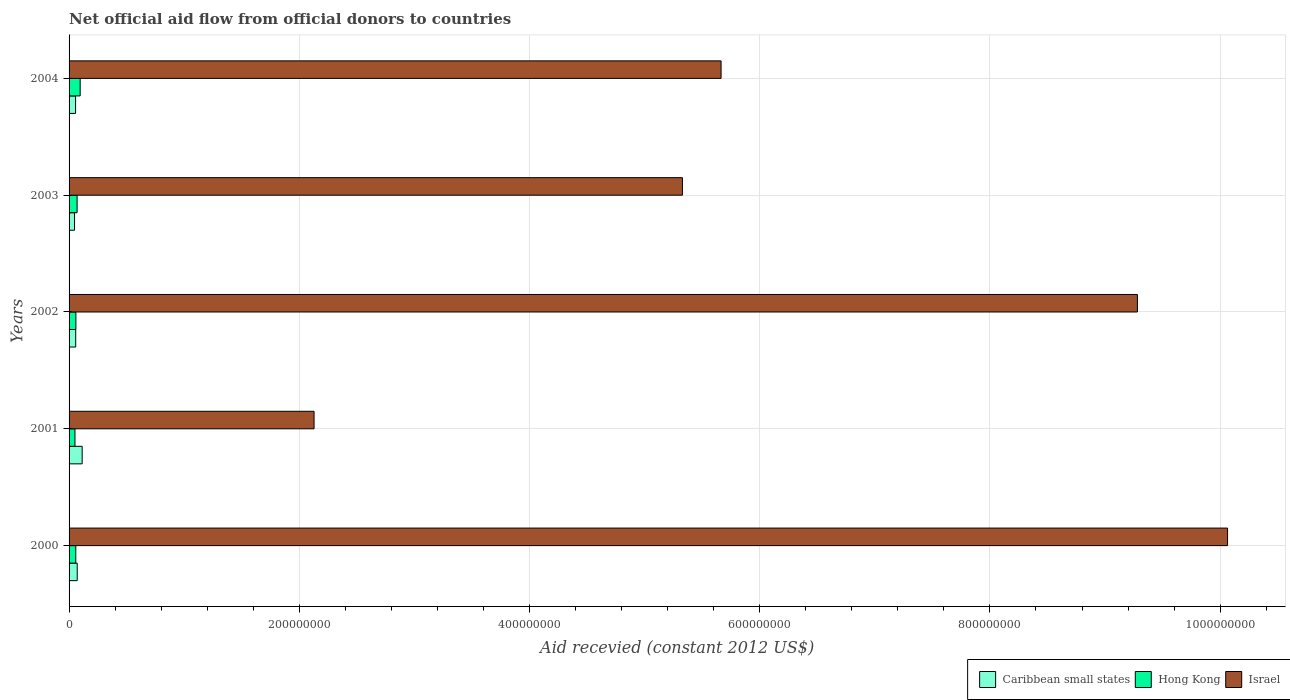How many different coloured bars are there?
Offer a terse response. 3. How many groups of bars are there?
Give a very brief answer. 5. How many bars are there on the 5th tick from the bottom?
Provide a short and direct response. 3. What is the total aid received in Caribbean small states in 2002?
Provide a short and direct response. 5.78e+06. Across all years, what is the maximum total aid received in Caribbean small states?
Make the answer very short. 1.14e+07. Across all years, what is the minimum total aid received in Israel?
Your answer should be compact. 2.13e+08. In which year was the total aid received in Israel maximum?
Offer a very short reply. 2000. What is the total total aid received in Hong Kong in the graph?
Your response must be concise. 3.35e+07. What is the difference between the total aid received in Caribbean small states in 2000 and that in 2004?
Keep it short and to the point. 1.42e+06. What is the difference between the total aid received in Israel in 2000 and the total aid received in Caribbean small states in 2003?
Your answer should be very brief. 1.00e+09. What is the average total aid received in Hong Kong per year?
Offer a very short reply. 6.70e+06. In the year 2000, what is the difference between the total aid received in Israel and total aid received in Hong Kong?
Make the answer very short. 1.00e+09. What is the ratio of the total aid received in Hong Kong in 2000 to that in 2004?
Offer a terse response. 0.6. Is the total aid received in Caribbean small states in 2000 less than that in 2002?
Offer a terse response. No. Is the difference between the total aid received in Israel in 2003 and 2004 greater than the difference between the total aid received in Hong Kong in 2003 and 2004?
Provide a succinct answer. No. What is the difference between the highest and the second highest total aid received in Caribbean small states?
Your answer should be very brief. 4.30e+06. What is the difference between the highest and the lowest total aid received in Israel?
Provide a short and direct response. 7.94e+08. Is the sum of the total aid received in Israel in 2002 and 2003 greater than the maximum total aid received in Caribbean small states across all years?
Make the answer very short. Yes. What does the 2nd bar from the top in 2002 represents?
Offer a terse response. Hong Kong. What does the 2nd bar from the bottom in 2002 represents?
Your answer should be compact. Hong Kong. Is it the case that in every year, the sum of the total aid received in Caribbean small states and total aid received in Israel is greater than the total aid received in Hong Kong?
Your response must be concise. Yes. How many bars are there?
Your response must be concise. 15. How many years are there in the graph?
Offer a very short reply. 5. What is the difference between two consecutive major ticks on the X-axis?
Offer a terse response. 2.00e+08. Are the values on the major ticks of X-axis written in scientific E-notation?
Your response must be concise. No. Does the graph contain any zero values?
Offer a terse response. No. Where does the legend appear in the graph?
Your answer should be compact. Bottom right. How many legend labels are there?
Offer a very short reply. 3. What is the title of the graph?
Provide a short and direct response. Net official aid flow from official donors to countries. What is the label or title of the X-axis?
Your answer should be very brief. Aid recevied (constant 2012 US$). What is the Aid recevied (constant 2012 US$) of Caribbean small states in 2000?
Your response must be concise. 7.08e+06. What is the Aid recevied (constant 2012 US$) in Hong Kong in 2000?
Your answer should be very brief. 5.83e+06. What is the Aid recevied (constant 2012 US$) in Israel in 2000?
Ensure brevity in your answer.  1.01e+09. What is the Aid recevied (constant 2012 US$) in Caribbean small states in 2001?
Give a very brief answer. 1.14e+07. What is the Aid recevied (constant 2012 US$) in Hong Kong in 2001?
Give a very brief answer. 5.12e+06. What is the Aid recevied (constant 2012 US$) in Israel in 2001?
Provide a short and direct response. 2.13e+08. What is the Aid recevied (constant 2012 US$) of Caribbean small states in 2002?
Make the answer very short. 5.78e+06. What is the Aid recevied (constant 2012 US$) in Hong Kong in 2002?
Your answer should be very brief. 5.92e+06. What is the Aid recevied (constant 2012 US$) in Israel in 2002?
Make the answer very short. 9.28e+08. What is the Aid recevied (constant 2012 US$) of Caribbean small states in 2003?
Keep it short and to the point. 4.76e+06. What is the Aid recevied (constant 2012 US$) in Hong Kong in 2003?
Offer a terse response. 6.99e+06. What is the Aid recevied (constant 2012 US$) in Israel in 2003?
Offer a very short reply. 5.33e+08. What is the Aid recevied (constant 2012 US$) of Caribbean small states in 2004?
Your answer should be very brief. 5.66e+06. What is the Aid recevied (constant 2012 US$) of Hong Kong in 2004?
Offer a terse response. 9.65e+06. What is the Aid recevied (constant 2012 US$) of Israel in 2004?
Your response must be concise. 5.66e+08. Across all years, what is the maximum Aid recevied (constant 2012 US$) in Caribbean small states?
Offer a very short reply. 1.14e+07. Across all years, what is the maximum Aid recevied (constant 2012 US$) in Hong Kong?
Offer a terse response. 9.65e+06. Across all years, what is the maximum Aid recevied (constant 2012 US$) of Israel?
Provide a succinct answer. 1.01e+09. Across all years, what is the minimum Aid recevied (constant 2012 US$) in Caribbean small states?
Make the answer very short. 4.76e+06. Across all years, what is the minimum Aid recevied (constant 2012 US$) of Hong Kong?
Your response must be concise. 5.12e+06. Across all years, what is the minimum Aid recevied (constant 2012 US$) of Israel?
Keep it short and to the point. 2.13e+08. What is the total Aid recevied (constant 2012 US$) in Caribbean small states in the graph?
Provide a short and direct response. 3.47e+07. What is the total Aid recevied (constant 2012 US$) of Hong Kong in the graph?
Offer a very short reply. 3.35e+07. What is the total Aid recevied (constant 2012 US$) in Israel in the graph?
Ensure brevity in your answer.  3.25e+09. What is the difference between the Aid recevied (constant 2012 US$) in Caribbean small states in 2000 and that in 2001?
Provide a succinct answer. -4.30e+06. What is the difference between the Aid recevied (constant 2012 US$) of Hong Kong in 2000 and that in 2001?
Your answer should be compact. 7.10e+05. What is the difference between the Aid recevied (constant 2012 US$) of Israel in 2000 and that in 2001?
Ensure brevity in your answer.  7.94e+08. What is the difference between the Aid recevied (constant 2012 US$) in Caribbean small states in 2000 and that in 2002?
Offer a very short reply. 1.30e+06. What is the difference between the Aid recevied (constant 2012 US$) of Hong Kong in 2000 and that in 2002?
Offer a very short reply. -9.00e+04. What is the difference between the Aid recevied (constant 2012 US$) in Israel in 2000 and that in 2002?
Your answer should be very brief. 7.83e+07. What is the difference between the Aid recevied (constant 2012 US$) in Caribbean small states in 2000 and that in 2003?
Ensure brevity in your answer.  2.32e+06. What is the difference between the Aid recevied (constant 2012 US$) in Hong Kong in 2000 and that in 2003?
Your response must be concise. -1.16e+06. What is the difference between the Aid recevied (constant 2012 US$) in Israel in 2000 and that in 2003?
Provide a succinct answer. 4.74e+08. What is the difference between the Aid recevied (constant 2012 US$) of Caribbean small states in 2000 and that in 2004?
Your response must be concise. 1.42e+06. What is the difference between the Aid recevied (constant 2012 US$) of Hong Kong in 2000 and that in 2004?
Keep it short and to the point. -3.82e+06. What is the difference between the Aid recevied (constant 2012 US$) in Israel in 2000 and that in 2004?
Your response must be concise. 4.40e+08. What is the difference between the Aid recevied (constant 2012 US$) in Caribbean small states in 2001 and that in 2002?
Keep it short and to the point. 5.60e+06. What is the difference between the Aid recevied (constant 2012 US$) of Hong Kong in 2001 and that in 2002?
Provide a short and direct response. -8.00e+05. What is the difference between the Aid recevied (constant 2012 US$) of Israel in 2001 and that in 2002?
Give a very brief answer. -7.15e+08. What is the difference between the Aid recevied (constant 2012 US$) in Caribbean small states in 2001 and that in 2003?
Provide a succinct answer. 6.62e+06. What is the difference between the Aid recevied (constant 2012 US$) of Hong Kong in 2001 and that in 2003?
Ensure brevity in your answer.  -1.87e+06. What is the difference between the Aid recevied (constant 2012 US$) of Israel in 2001 and that in 2003?
Your answer should be compact. -3.20e+08. What is the difference between the Aid recevied (constant 2012 US$) in Caribbean small states in 2001 and that in 2004?
Offer a terse response. 5.72e+06. What is the difference between the Aid recevied (constant 2012 US$) of Hong Kong in 2001 and that in 2004?
Offer a terse response. -4.53e+06. What is the difference between the Aid recevied (constant 2012 US$) in Israel in 2001 and that in 2004?
Offer a terse response. -3.54e+08. What is the difference between the Aid recevied (constant 2012 US$) of Caribbean small states in 2002 and that in 2003?
Your response must be concise. 1.02e+06. What is the difference between the Aid recevied (constant 2012 US$) of Hong Kong in 2002 and that in 2003?
Offer a very short reply. -1.07e+06. What is the difference between the Aid recevied (constant 2012 US$) of Israel in 2002 and that in 2003?
Provide a succinct answer. 3.95e+08. What is the difference between the Aid recevied (constant 2012 US$) in Caribbean small states in 2002 and that in 2004?
Make the answer very short. 1.20e+05. What is the difference between the Aid recevied (constant 2012 US$) of Hong Kong in 2002 and that in 2004?
Offer a terse response. -3.73e+06. What is the difference between the Aid recevied (constant 2012 US$) in Israel in 2002 and that in 2004?
Your answer should be compact. 3.62e+08. What is the difference between the Aid recevied (constant 2012 US$) of Caribbean small states in 2003 and that in 2004?
Keep it short and to the point. -9.00e+05. What is the difference between the Aid recevied (constant 2012 US$) of Hong Kong in 2003 and that in 2004?
Provide a succinct answer. -2.66e+06. What is the difference between the Aid recevied (constant 2012 US$) of Israel in 2003 and that in 2004?
Offer a terse response. -3.36e+07. What is the difference between the Aid recevied (constant 2012 US$) in Caribbean small states in 2000 and the Aid recevied (constant 2012 US$) in Hong Kong in 2001?
Make the answer very short. 1.96e+06. What is the difference between the Aid recevied (constant 2012 US$) of Caribbean small states in 2000 and the Aid recevied (constant 2012 US$) of Israel in 2001?
Offer a terse response. -2.06e+08. What is the difference between the Aid recevied (constant 2012 US$) in Hong Kong in 2000 and the Aid recevied (constant 2012 US$) in Israel in 2001?
Your answer should be very brief. -2.07e+08. What is the difference between the Aid recevied (constant 2012 US$) of Caribbean small states in 2000 and the Aid recevied (constant 2012 US$) of Hong Kong in 2002?
Offer a terse response. 1.16e+06. What is the difference between the Aid recevied (constant 2012 US$) in Caribbean small states in 2000 and the Aid recevied (constant 2012 US$) in Israel in 2002?
Your answer should be compact. -9.21e+08. What is the difference between the Aid recevied (constant 2012 US$) in Hong Kong in 2000 and the Aid recevied (constant 2012 US$) in Israel in 2002?
Make the answer very short. -9.22e+08. What is the difference between the Aid recevied (constant 2012 US$) of Caribbean small states in 2000 and the Aid recevied (constant 2012 US$) of Israel in 2003?
Your answer should be compact. -5.26e+08. What is the difference between the Aid recevied (constant 2012 US$) in Hong Kong in 2000 and the Aid recevied (constant 2012 US$) in Israel in 2003?
Keep it short and to the point. -5.27e+08. What is the difference between the Aid recevied (constant 2012 US$) in Caribbean small states in 2000 and the Aid recevied (constant 2012 US$) in Hong Kong in 2004?
Give a very brief answer. -2.57e+06. What is the difference between the Aid recevied (constant 2012 US$) in Caribbean small states in 2000 and the Aid recevied (constant 2012 US$) in Israel in 2004?
Make the answer very short. -5.59e+08. What is the difference between the Aid recevied (constant 2012 US$) of Hong Kong in 2000 and the Aid recevied (constant 2012 US$) of Israel in 2004?
Give a very brief answer. -5.61e+08. What is the difference between the Aid recevied (constant 2012 US$) in Caribbean small states in 2001 and the Aid recevied (constant 2012 US$) in Hong Kong in 2002?
Offer a terse response. 5.46e+06. What is the difference between the Aid recevied (constant 2012 US$) in Caribbean small states in 2001 and the Aid recevied (constant 2012 US$) in Israel in 2002?
Offer a terse response. -9.17e+08. What is the difference between the Aid recevied (constant 2012 US$) of Hong Kong in 2001 and the Aid recevied (constant 2012 US$) of Israel in 2002?
Your response must be concise. -9.23e+08. What is the difference between the Aid recevied (constant 2012 US$) in Caribbean small states in 2001 and the Aid recevied (constant 2012 US$) in Hong Kong in 2003?
Ensure brevity in your answer.  4.39e+06. What is the difference between the Aid recevied (constant 2012 US$) of Caribbean small states in 2001 and the Aid recevied (constant 2012 US$) of Israel in 2003?
Make the answer very short. -5.21e+08. What is the difference between the Aid recevied (constant 2012 US$) of Hong Kong in 2001 and the Aid recevied (constant 2012 US$) of Israel in 2003?
Your answer should be very brief. -5.28e+08. What is the difference between the Aid recevied (constant 2012 US$) in Caribbean small states in 2001 and the Aid recevied (constant 2012 US$) in Hong Kong in 2004?
Your response must be concise. 1.73e+06. What is the difference between the Aid recevied (constant 2012 US$) in Caribbean small states in 2001 and the Aid recevied (constant 2012 US$) in Israel in 2004?
Make the answer very short. -5.55e+08. What is the difference between the Aid recevied (constant 2012 US$) in Hong Kong in 2001 and the Aid recevied (constant 2012 US$) in Israel in 2004?
Offer a terse response. -5.61e+08. What is the difference between the Aid recevied (constant 2012 US$) in Caribbean small states in 2002 and the Aid recevied (constant 2012 US$) in Hong Kong in 2003?
Your answer should be compact. -1.21e+06. What is the difference between the Aid recevied (constant 2012 US$) in Caribbean small states in 2002 and the Aid recevied (constant 2012 US$) in Israel in 2003?
Offer a terse response. -5.27e+08. What is the difference between the Aid recevied (constant 2012 US$) in Hong Kong in 2002 and the Aid recevied (constant 2012 US$) in Israel in 2003?
Keep it short and to the point. -5.27e+08. What is the difference between the Aid recevied (constant 2012 US$) of Caribbean small states in 2002 and the Aid recevied (constant 2012 US$) of Hong Kong in 2004?
Offer a very short reply. -3.87e+06. What is the difference between the Aid recevied (constant 2012 US$) in Caribbean small states in 2002 and the Aid recevied (constant 2012 US$) in Israel in 2004?
Provide a short and direct response. -5.61e+08. What is the difference between the Aid recevied (constant 2012 US$) in Hong Kong in 2002 and the Aid recevied (constant 2012 US$) in Israel in 2004?
Offer a terse response. -5.61e+08. What is the difference between the Aid recevied (constant 2012 US$) in Caribbean small states in 2003 and the Aid recevied (constant 2012 US$) in Hong Kong in 2004?
Provide a short and direct response. -4.89e+06. What is the difference between the Aid recevied (constant 2012 US$) in Caribbean small states in 2003 and the Aid recevied (constant 2012 US$) in Israel in 2004?
Provide a short and direct response. -5.62e+08. What is the difference between the Aid recevied (constant 2012 US$) in Hong Kong in 2003 and the Aid recevied (constant 2012 US$) in Israel in 2004?
Offer a terse response. -5.59e+08. What is the average Aid recevied (constant 2012 US$) in Caribbean small states per year?
Your answer should be very brief. 6.93e+06. What is the average Aid recevied (constant 2012 US$) of Hong Kong per year?
Keep it short and to the point. 6.70e+06. What is the average Aid recevied (constant 2012 US$) of Israel per year?
Provide a succinct answer. 6.49e+08. In the year 2000, what is the difference between the Aid recevied (constant 2012 US$) of Caribbean small states and Aid recevied (constant 2012 US$) of Hong Kong?
Make the answer very short. 1.25e+06. In the year 2000, what is the difference between the Aid recevied (constant 2012 US$) in Caribbean small states and Aid recevied (constant 2012 US$) in Israel?
Ensure brevity in your answer.  -9.99e+08. In the year 2000, what is the difference between the Aid recevied (constant 2012 US$) in Hong Kong and Aid recevied (constant 2012 US$) in Israel?
Your response must be concise. -1.00e+09. In the year 2001, what is the difference between the Aid recevied (constant 2012 US$) of Caribbean small states and Aid recevied (constant 2012 US$) of Hong Kong?
Keep it short and to the point. 6.26e+06. In the year 2001, what is the difference between the Aid recevied (constant 2012 US$) of Caribbean small states and Aid recevied (constant 2012 US$) of Israel?
Keep it short and to the point. -2.01e+08. In the year 2001, what is the difference between the Aid recevied (constant 2012 US$) in Hong Kong and Aid recevied (constant 2012 US$) in Israel?
Offer a terse response. -2.08e+08. In the year 2002, what is the difference between the Aid recevied (constant 2012 US$) in Caribbean small states and Aid recevied (constant 2012 US$) in Hong Kong?
Your answer should be very brief. -1.40e+05. In the year 2002, what is the difference between the Aid recevied (constant 2012 US$) in Caribbean small states and Aid recevied (constant 2012 US$) in Israel?
Provide a succinct answer. -9.22e+08. In the year 2002, what is the difference between the Aid recevied (constant 2012 US$) of Hong Kong and Aid recevied (constant 2012 US$) of Israel?
Offer a terse response. -9.22e+08. In the year 2003, what is the difference between the Aid recevied (constant 2012 US$) in Caribbean small states and Aid recevied (constant 2012 US$) in Hong Kong?
Provide a short and direct response. -2.23e+06. In the year 2003, what is the difference between the Aid recevied (constant 2012 US$) of Caribbean small states and Aid recevied (constant 2012 US$) of Israel?
Provide a short and direct response. -5.28e+08. In the year 2003, what is the difference between the Aid recevied (constant 2012 US$) of Hong Kong and Aid recevied (constant 2012 US$) of Israel?
Make the answer very short. -5.26e+08. In the year 2004, what is the difference between the Aid recevied (constant 2012 US$) in Caribbean small states and Aid recevied (constant 2012 US$) in Hong Kong?
Offer a terse response. -3.99e+06. In the year 2004, what is the difference between the Aid recevied (constant 2012 US$) of Caribbean small states and Aid recevied (constant 2012 US$) of Israel?
Ensure brevity in your answer.  -5.61e+08. In the year 2004, what is the difference between the Aid recevied (constant 2012 US$) of Hong Kong and Aid recevied (constant 2012 US$) of Israel?
Your response must be concise. -5.57e+08. What is the ratio of the Aid recevied (constant 2012 US$) in Caribbean small states in 2000 to that in 2001?
Provide a succinct answer. 0.62. What is the ratio of the Aid recevied (constant 2012 US$) in Hong Kong in 2000 to that in 2001?
Offer a terse response. 1.14. What is the ratio of the Aid recevied (constant 2012 US$) in Israel in 2000 to that in 2001?
Keep it short and to the point. 4.73. What is the ratio of the Aid recevied (constant 2012 US$) in Caribbean small states in 2000 to that in 2002?
Make the answer very short. 1.22. What is the ratio of the Aid recevied (constant 2012 US$) of Hong Kong in 2000 to that in 2002?
Provide a short and direct response. 0.98. What is the ratio of the Aid recevied (constant 2012 US$) of Israel in 2000 to that in 2002?
Ensure brevity in your answer.  1.08. What is the ratio of the Aid recevied (constant 2012 US$) in Caribbean small states in 2000 to that in 2003?
Ensure brevity in your answer.  1.49. What is the ratio of the Aid recevied (constant 2012 US$) in Hong Kong in 2000 to that in 2003?
Ensure brevity in your answer.  0.83. What is the ratio of the Aid recevied (constant 2012 US$) in Israel in 2000 to that in 2003?
Your answer should be very brief. 1.89. What is the ratio of the Aid recevied (constant 2012 US$) in Caribbean small states in 2000 to that in 2004?
Your answer should be very brief. 1.25. What is the ratio of the Aid recevied (constant 2012 US$) in Hong Kong in 2000 to that in 2004?
Offer a terse response. 0.6. What is the ratio of the Aid recevied (constant 2012 US$) of Israel in 2000 to that in 2004?
Your response must be concise. 1.78. What is the ratio of the Aid recevied (constant 2012 US$) in Caribbean small states in 2001 to that in 2002?
Provide a succinct answer. 1.97. What is the ratio of the Aid recevied (constant 2012 US$) in Hong Kong in 2001 to that in 2002?
Offer a terse response. 0.86. What is the ratio of the Aid recevied (constant 2012 US$) of Israel in 2001 to that in 2002?
Ensure brevity in your answer.  0.23. What is the ratio of the Aid recevied (constant 2012 US$) in Caribbean small states in 2001 to that in 2003?
Make the answer very short. 2.39. What is the ratio of the Aid recevied (constant 2012 US$) in Hong Kong in 2001 to that in 2003?
Make the answer very short. 0.73. What is the ratio of the Aid recevied (constant 2012 US$) in Israel in 2001 to that in 2003?
Provide a short and direct response. 0.4. What is the ratio of the Aid recevied (constant 2012 US$) of Caribbean small states in 2001 to that in 2004?
Offer a very short reply. 2.01. What is the ratio of the Aid recevied (constant 2012 US$) of Hong Kong in 2001 to that in 2004?
Offer a very short reply. 0.53. What is the ratio of the Aid recevied (constant 2012 US$) of Israel in 2001 to that in 2004?
Give a very brief answer. 0.38. What is the ratio of the Aid recevied (constant 2012 US$) in Caribbean small states in 2002 to that in 2003?
Offer a very short reply. 1.21. What is the ratio of the Aid recevied (constant 2012 US$) in Hong Kong in 2002 to that in 2003?
Give a very brief answer. 0.85. What is the ratio of the Aid recevied (constant 2012 US$) in Israel in 2002 to that in 2003?
Offer a very short reply. 1.74. What is the ratio of the Aid recevied (constant 2012 US$) of Caribbean small states in 2002 to that in 2004?
Keep it short and to the point. 1.02. What is the ratio of the Aid recevied (constant 2012 US$) of Hong Kong in 2002 to that in 2004?
Your answer should be very brief. 0.61. What is the ratio of the Aid recevied (constant 2012 US$) in Israel in 2002 to that in 2004?
Offer a very short reply. 1.64. What is the ratio of the Aid recevied (constant 2012 US$) in Caribbean small states in 2003 to that in 2004?
Ensure brevity in your answer.  0.84. What is the ratio of the Aid recevied (constant 2012 US$) in Hong Kong in 2003 to that in 2004?
Offer a terse response. 0.72. What is the ratio of the Aid recevied (constant 2012 US$) of Israel in 2003 to that in 2004?
Ensure brevity in your answer.  0.94. What is the difference between the highest and the second highest Aid recevied (constant 2012 US$) of Caribbean small states?
Keep it short and to the point. 4.30e+06. What is the difference between the highest and the second highest Aid recevied (constant 2012 US$) of Hong Kong?
Provide a succinct answer. 2.66e+06. What is the difference between the highest and the second highest Aid recevied (constant 2012 US$) of Israel?
Provide a short and direct response. 7.83e+07. What is the difference between the highest and the lowest Aid recevied (constant 2012 US$) of Caribbean small states?
Give a very brief answer. 6.62e+06. What is the difference between the highest and the lowest Aid recevied (constant 2012 US$) in Hong Kong?
Offer a terse response. 4.53e+06. What is the difference between the highest and the lowest Aid recevied (constant 2012 US$) in Israel?
Your response must be concise. 7.94e+08. 